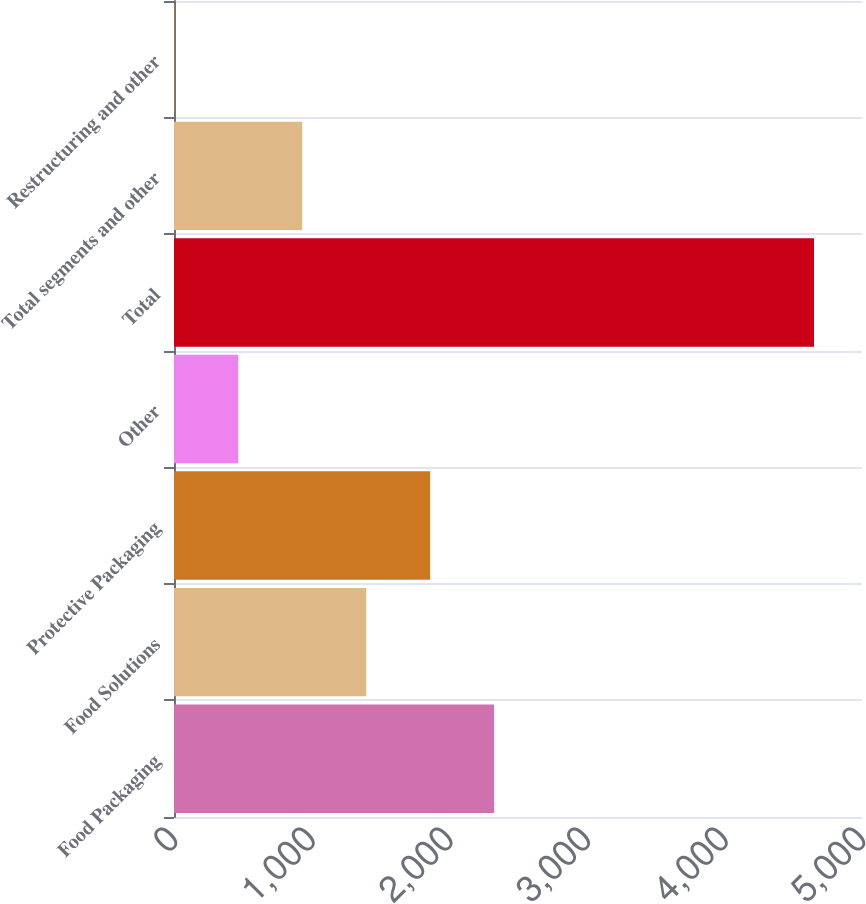Convert chart. <chart><loc_0><loc_0><loc_500><loc_500><bar_chart><fcel>Food Packaging<fcel>Food Solutions<fcel>Protective Packaging<fcel>Other<fcel>Total<fcel>Total segments and other<fcel>Restructuring and other<nl><fcel>2326.4<fcel>1396.48<fcel>1861.44<fcel>466.56<fcel>4651.2<fcel>931.52<fcel>1.6<nl></chart> 